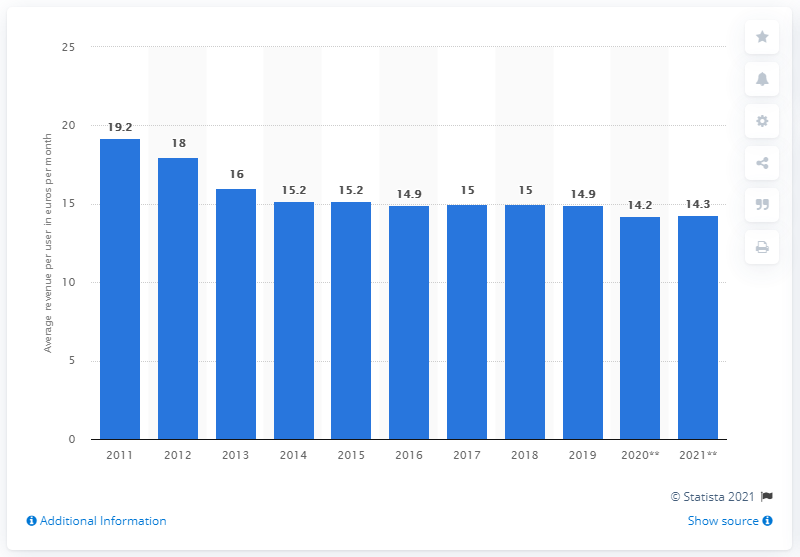Can you explain the trend in mobile broadband revenue per user shown in this chart? Certainly. The chart illustrates a declining trend in the average revenue per user (ARPU) of mobile broadband in Europe from 2011 to 2021. Initially, the ARPU was higher, peaking at €19.2 in 2011, but has generally decreased over the years. This could be due to increased competition among service providers, better data plans for consumers, or market saturation. 